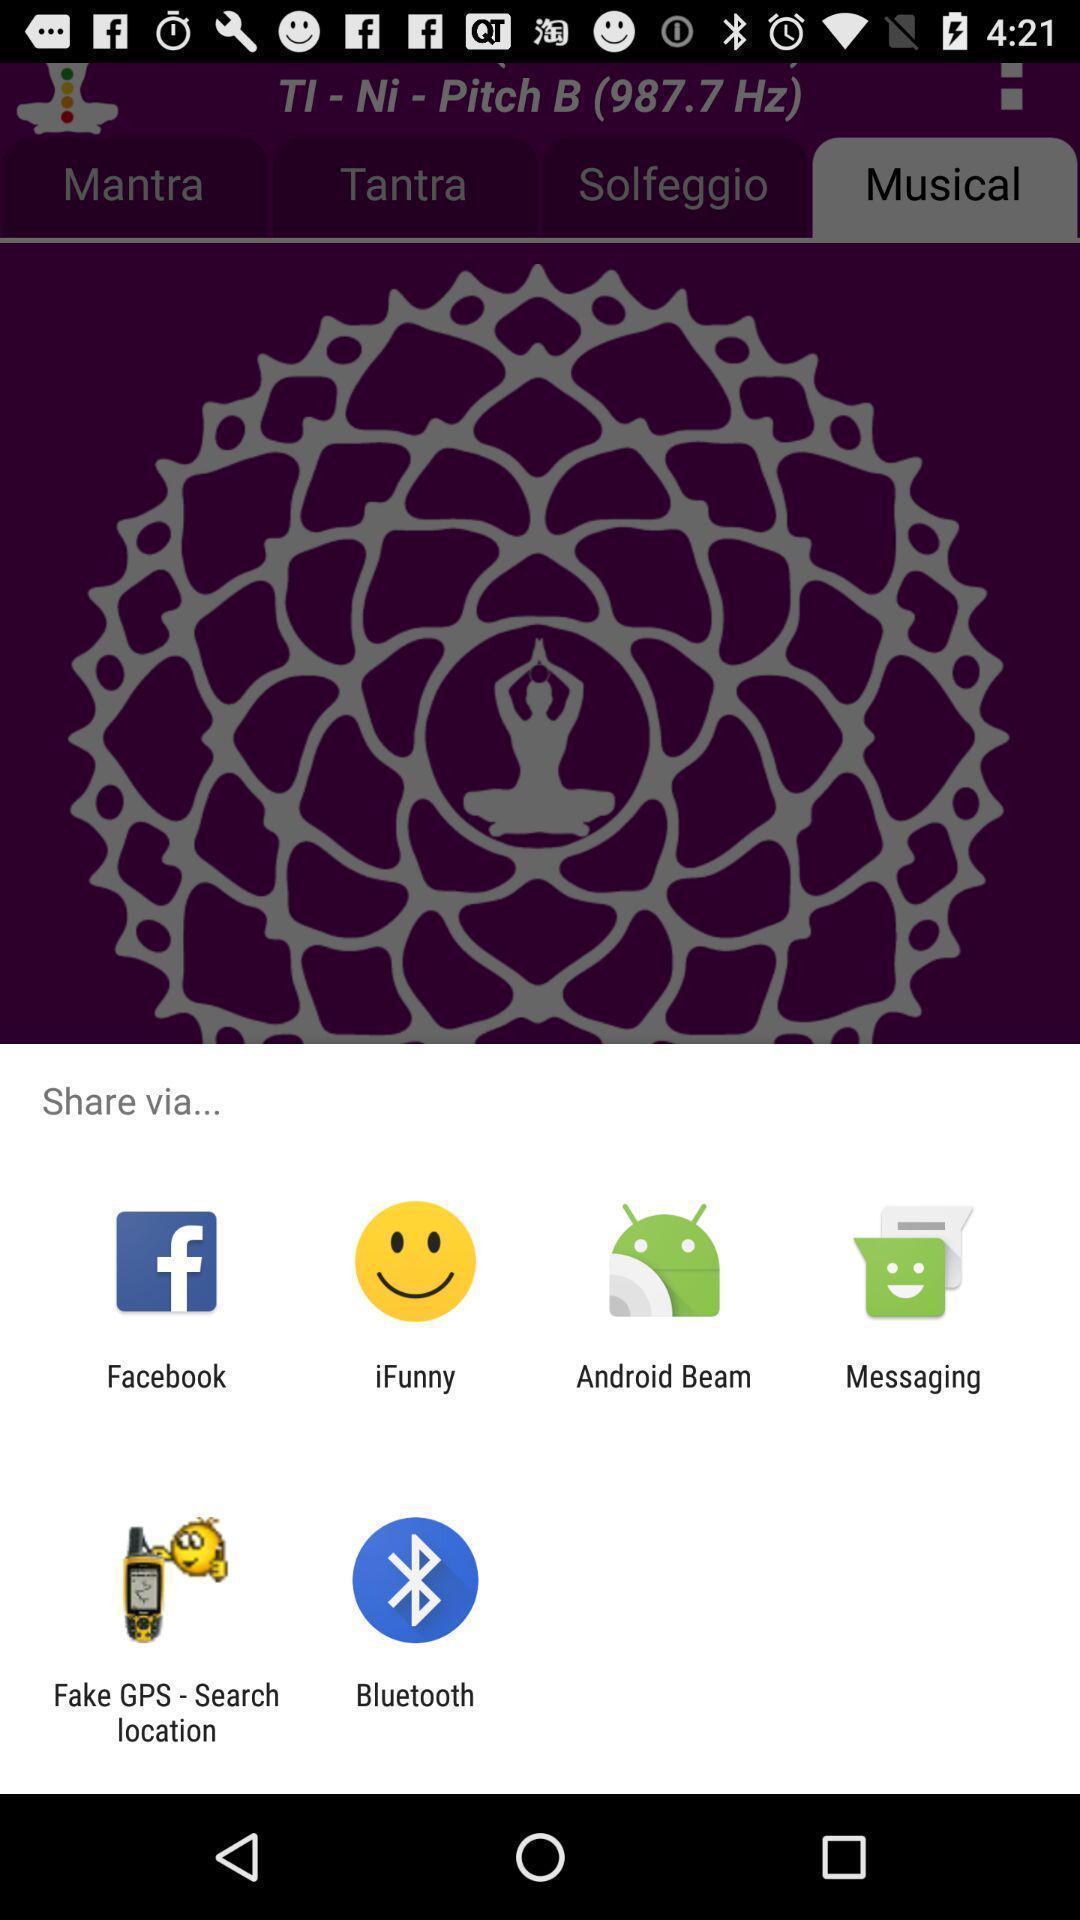What details can you identify in this image? Pop up page for sharing through different apps. 